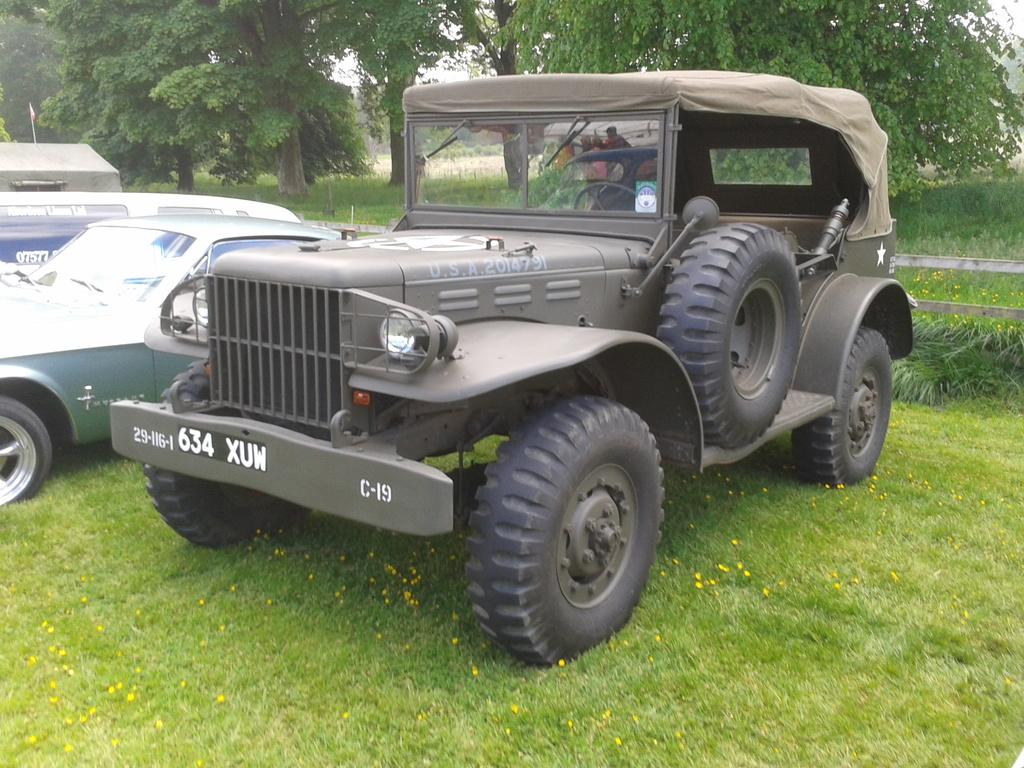What type of surface is visible in the foreground of the image? There is grass on the ground in the foreground of the image. What can be seen in the middle of the image? There are vehicles in the middle of the image. What type of vegetation is visible in the background of the image? There are trees in the background of the image. Is there any grass visible in the background of the image? Yes, there is grass visible in the background of the image. What type of wool is being used to cover the trees in the background of the image? There is no wool present in the image; the trees are not covered with any material. How many tickets are visible in the image? There are no tickets present in the image. 